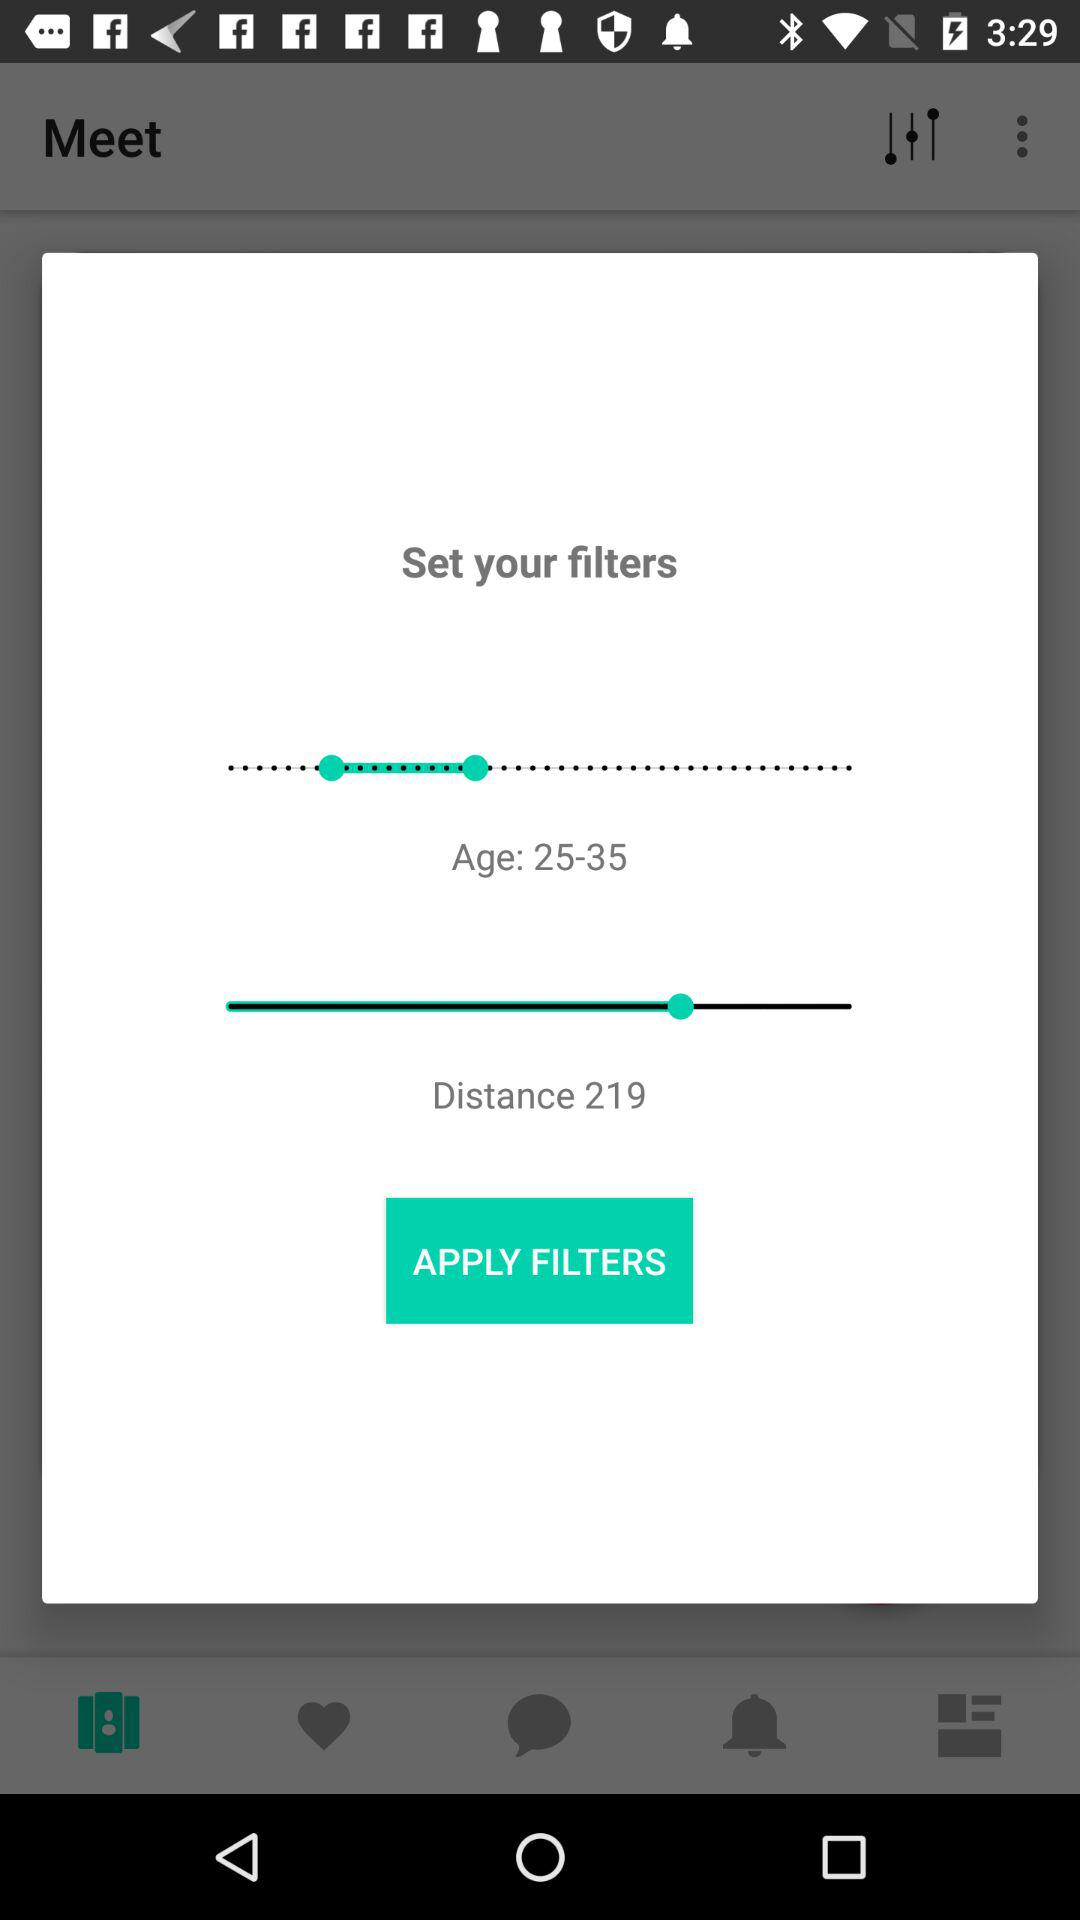What is the set age range? The set age range is from 25 to 35. 